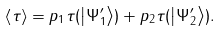<formula> <loc_0><loc_0><loc_500><loc_500>\left \langle \tau \right \rangle = p _ { 1 } \tau ( \left | \Psi _ { 1 } ^ { \prime } \right \rangle ) + p _ { 2 } \tau ( \left | \Psi _ { 2 } ^ { \prime } \right \rangle ) .</formula> 